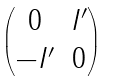<formula> <loc_0><loc_0><loc_500><loc_500>\begin{pmatrix} 0 & I ^ { \prime } \\ - I ^ { \prime } & 0 \end{pmatrix}</formula> 